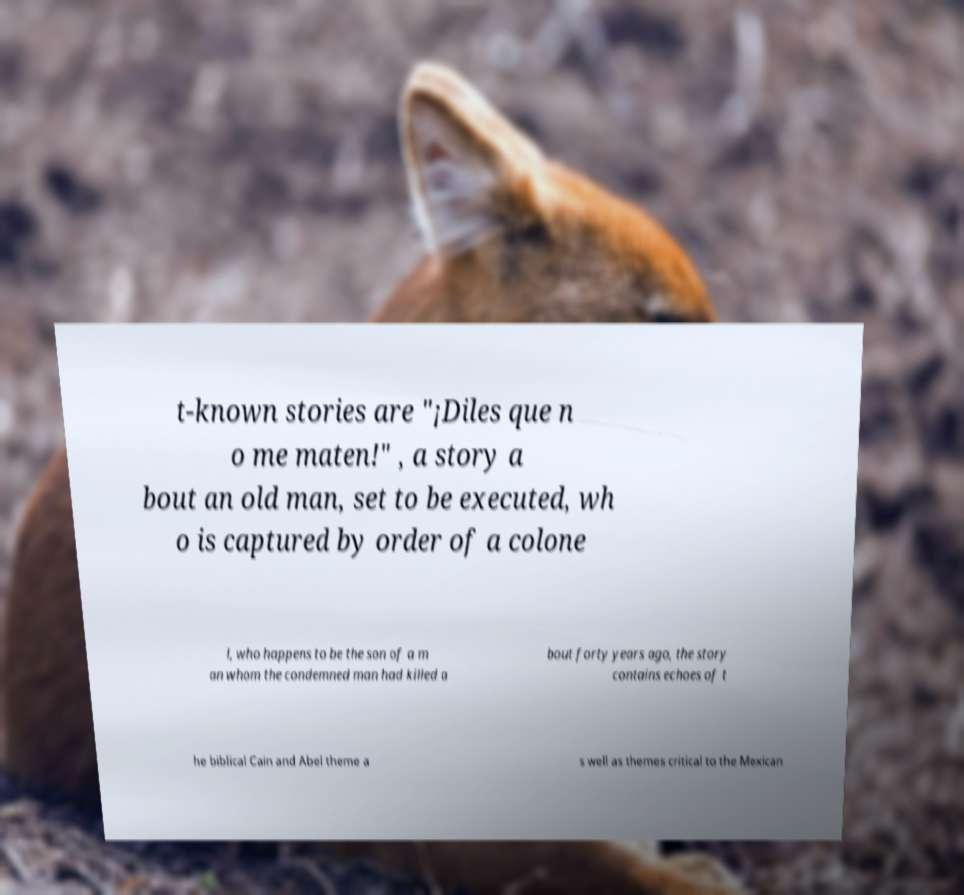For documentation purposes, I need the text within this image transcribed. Could you provide that? t-known stories are "¡Diles que n o me maten!" , a story a bout an old man, set to be executed, wh o is captured by order of a colone l, who happens to be the son of a m an whom the condemned man had killed a bout forty years ago, the story contains echoes of t he biblical Cain and Abel theme a s well as themes critical to the Mexican 